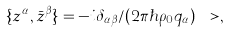Convert formula to latex. <formula><loc_0><loc_0><loc_500><loc_500>\{ z ^ { \alpha } , { \bar { z } } ^ { \beta } \} = - i \delta _ { \alpha \beta } / ( 2 \pi \hbar { \rho } _ { 0 } q _ { \alpha } ) \ > ,</formula> 